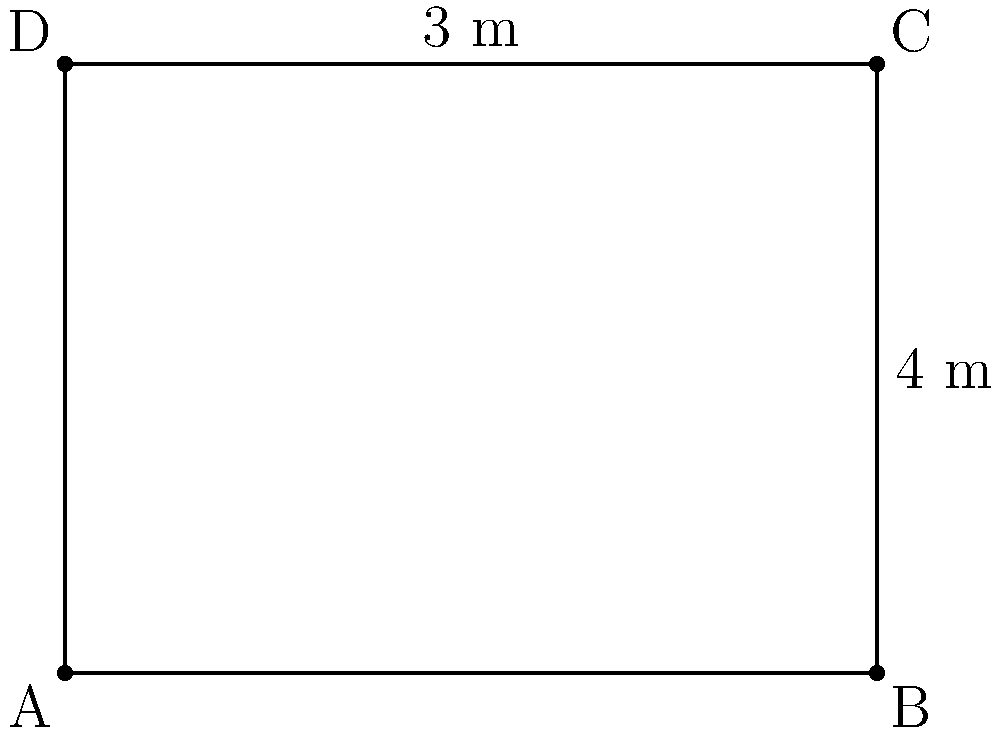In your HCV research lab, you need to calculate the area and perimeter of a rectangular lab bench to ensure proper decontamination procedures. The bench measures 4 meters in length and 3 meters in width. What is the total area of the bench in square meters, and what is its perimeter in meters? To solve this problem, we need to calculate both the area and perimeter of the rectangular lab bench.

1. Calculate the area:
   The formula for the area of a rectangle is: $A = l \times w$
   Where $A$ is the area, $l$ is the length, and $w$ is the width.
   
   $$A = 4 \text{ m} \times 3 \text{ m} = 12 \text{ m}^2$$

2. Calculate the perimeter:
   The formula for the perimeter of a rectangle is: $P = 2l + 2w$
   Where $P$ is the perimeter, $l$ is the length, and $w$ is the width.
   
   $$P = 2(4 \text{ m}) + 2(3 \text{ m}) = 8 \text{ m} + 6 \text{ m} = 14 \text{ m}$$

Therefore, the area of the lab bench is 12 square meters, and its perimeter is 14 meters.
Answer: Area: 12 m², Perimeter: 14 m 